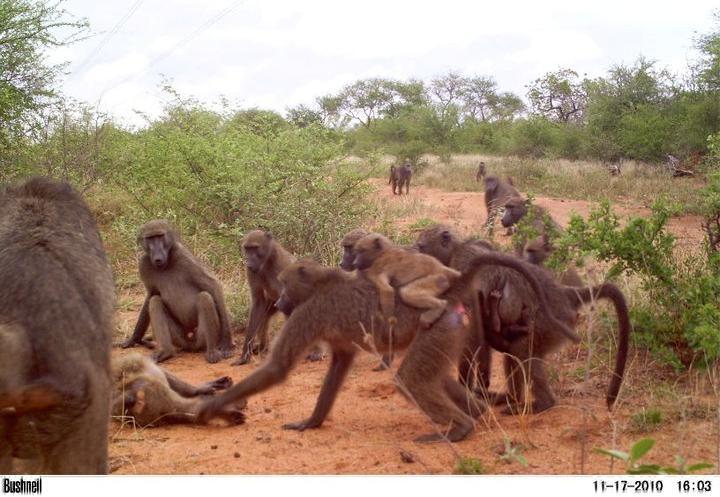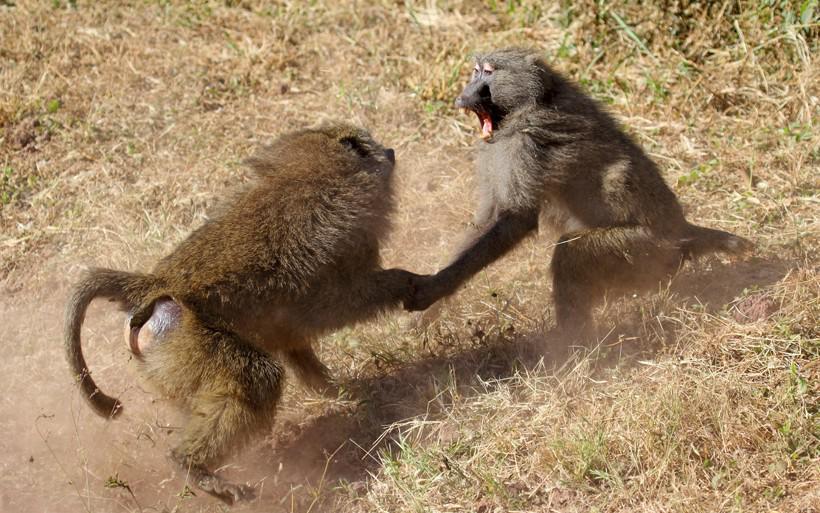The first image is the image on the left, the second image is the image on the right. For the images displayed, is the sentence "There's no more than two monkeys in the right image." factually correct? Answer yes or no. Yes. The first image is the image on the left, the second image is the image on the right. Evaluate the accuracy of this statement regarding the images: "The right image contains fewer than a third of the number of baboons on the left.". Is it true? Answer yes or no. Yes. 